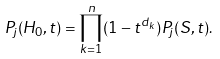<formula> <loc_0><loc_0><loc_500><loc_500>P _ { j } ( H _ { 0 } , t ) = \prod _ { k = 1 } ^ { n } ( 1 - t ^ { d _ { k } } ) P _ { j } ( S , t ) .</formula> 